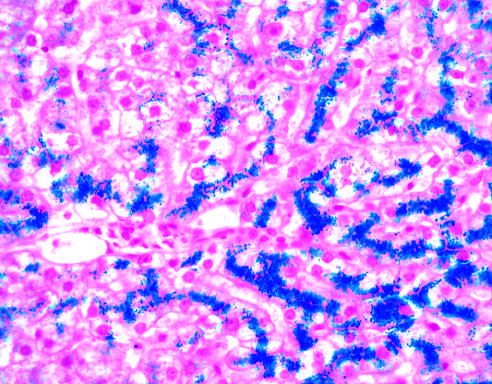what is normal at this stage of disease, even with such abundant iron?
Answer the question using a single word or phrase. The parenchymal architecture 